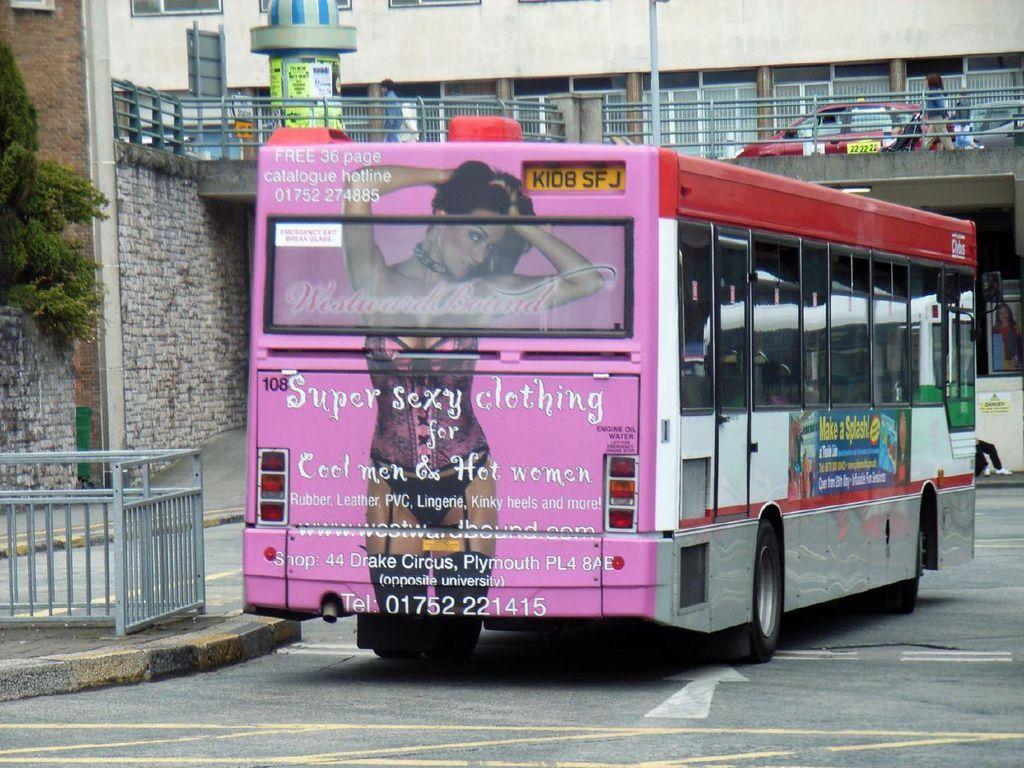Please provide a concise description of this image. In this picture there is a bus in the center of the image and there is a bridge at the top side of the image, on which there are cars and there is a tree on the left side of the image. 